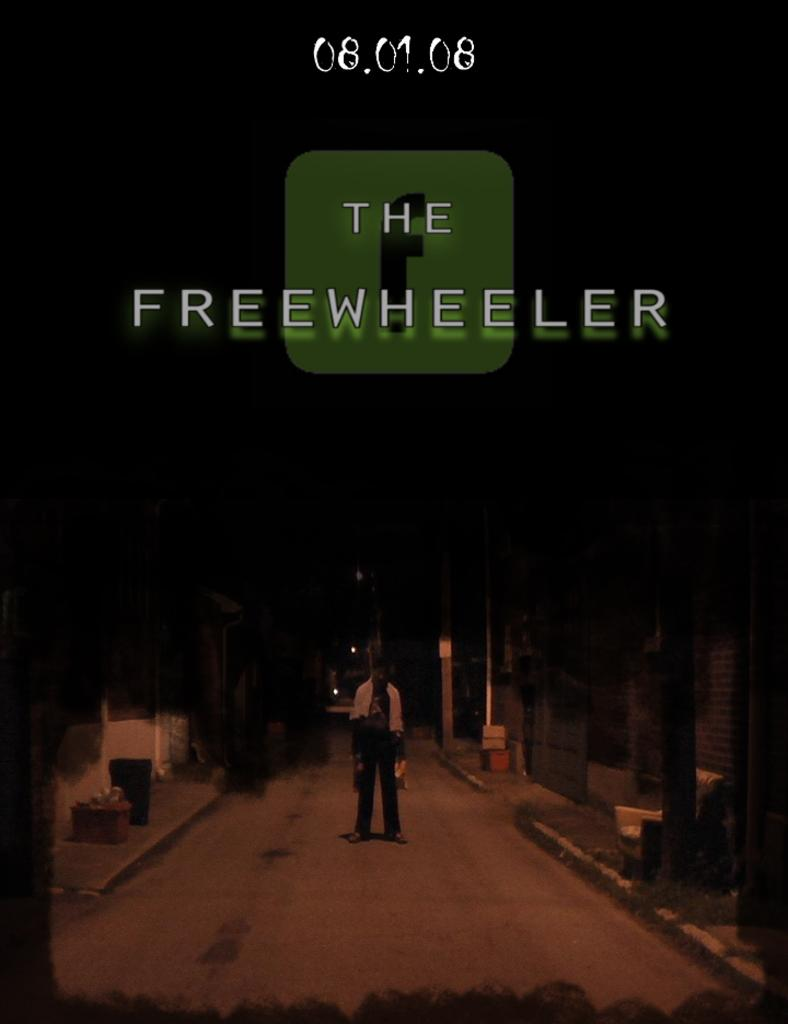<image>
Give a short and clear explanation of the subsequent image. poster for the freewheeler of someone standing in a road in the dark 